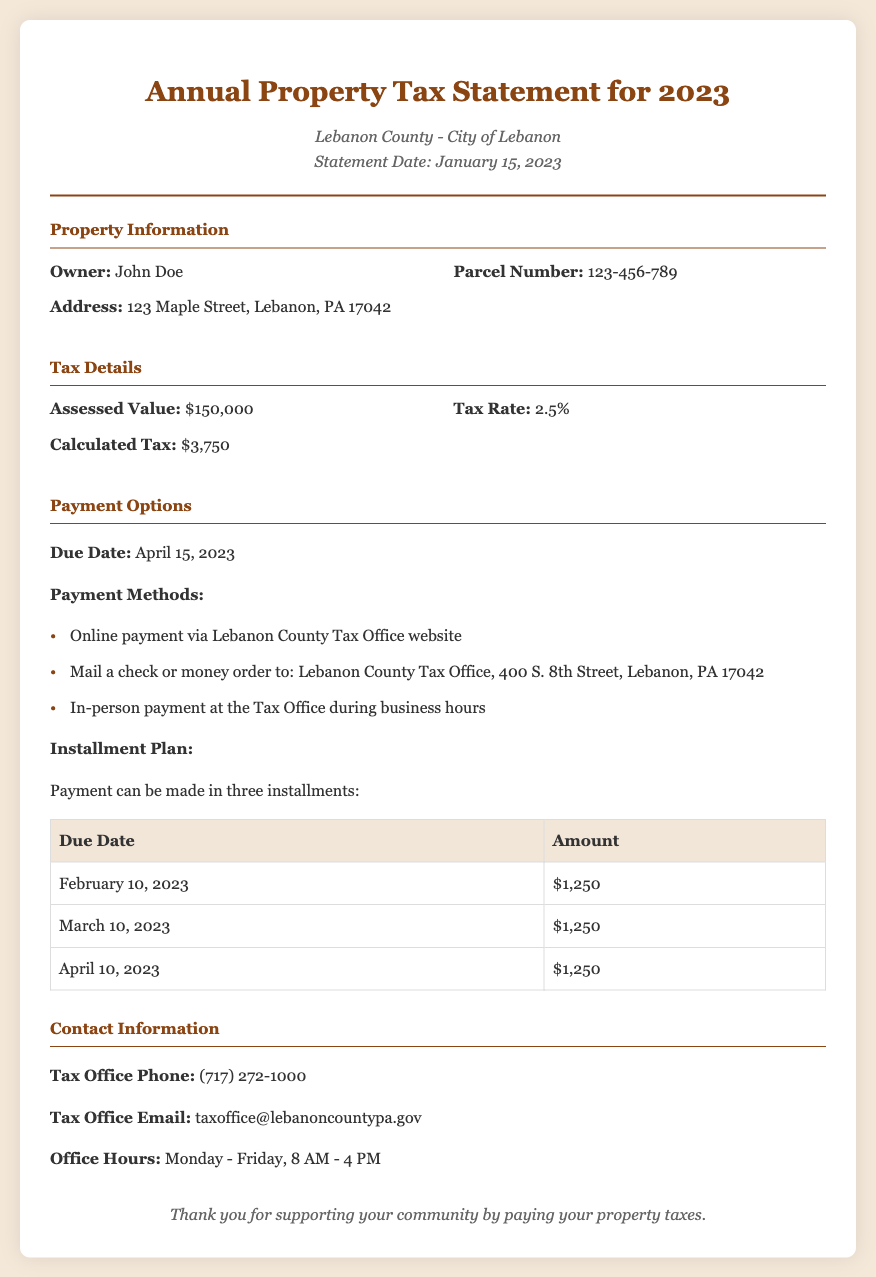What is the assessed value? The assessed value is specifically stated in the tax details section of the document.
Answer: $150,000 What is the tax rate? The tax rate is given in the tax details section and is expressed as a percentage.
Answer: 2.5% What is the due date for the payment? The due date is mentioned under the payment options section.
Answer: April 15, 2023 How many installments can the payment be made in? The installment information is provided in the payment options section of the document.
Answer: Three What is the calculated tax? The calculated tax is stated in the tax details section based on the assessed value and tax rate.
Answer: $3,750 What is the address for mailing the payment? The address for mailing payments is provided in the payment options section.
Answer: Lebanon County Tax Office, 400 S. 8th Street, Lebanon, PA 17042 What is the name of the document? The title of the document is bolded in the header section.
Answer: Annual Property Tax Statement for 2023 What is the contact phone number for the tax office? The contact phone number is specified in the contact information section of the document.
Answer: (717) 272-1000 What are the office hours for the tax office? The office hours are outlined in the contact information section.
Answer: Monday - Friday, 8 AM - 4 PM 